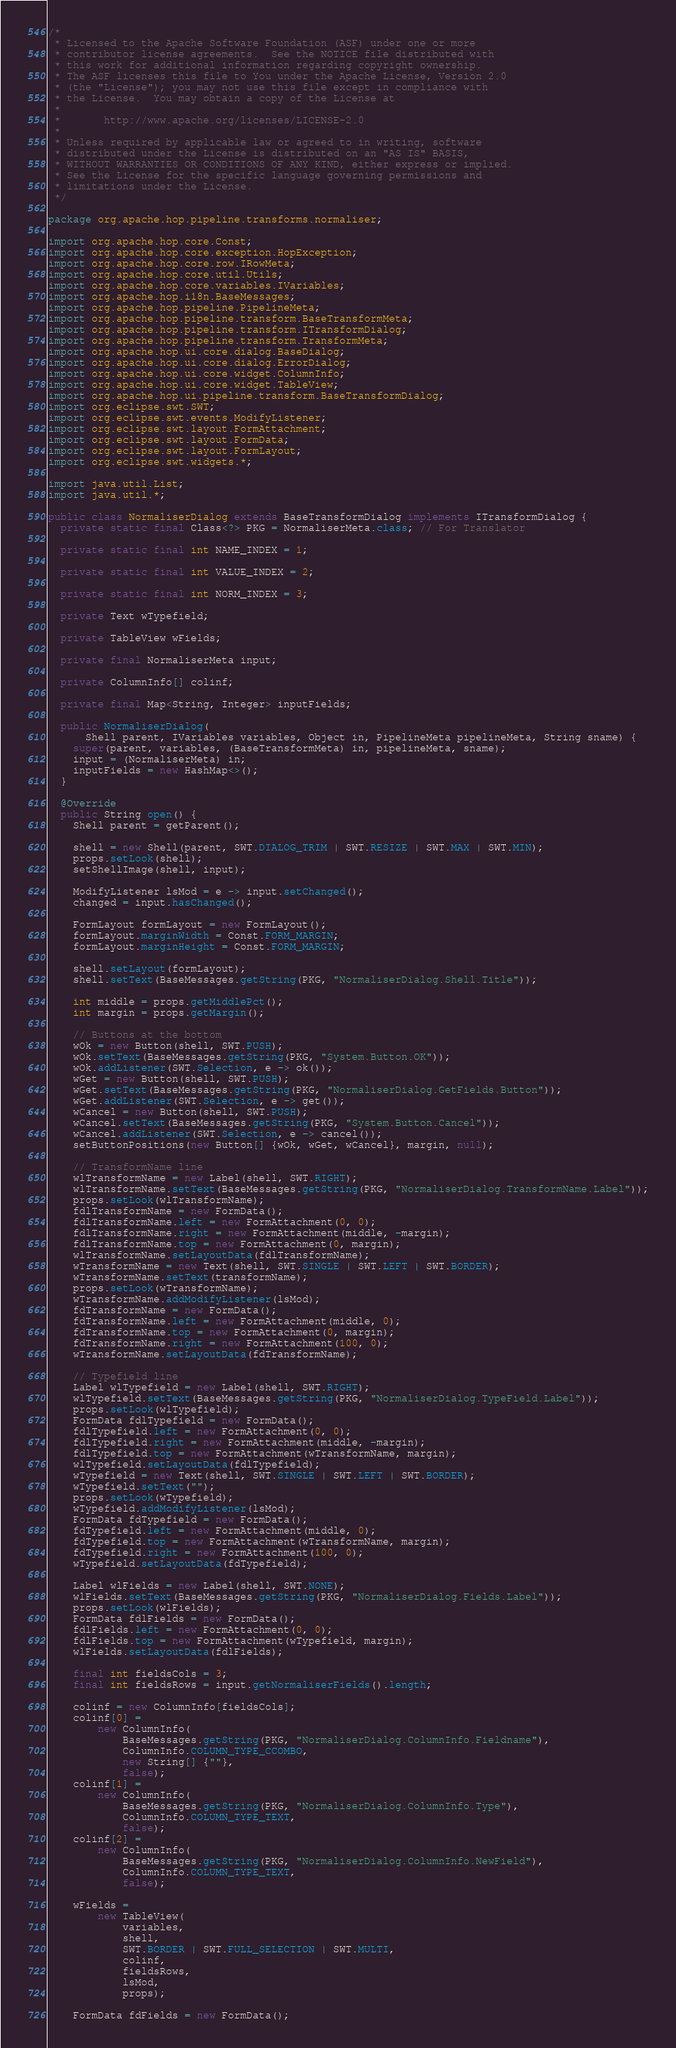Convert code to text. <code><loc_0><loc_0><loc_500><loc_500><_Java_>/*
 * Licensed to the Apache Software Foundation (ASF) under one or more
 * contributor license agreements.  See the NOTICE file distributed with
 * this work for additional information regarding copyright ownership.
 * The ASF licenses this file to You under the Apache License, Version 2.0
 * (the "License"); you may not use this file except in compliance with
 * the License.  You may obtain a copy of the License at
 *
 *       http://www.apache.org/licenses/LICENSE-2.0
 *
 * Unless required by applicable law or agreed to in writing, software
 * distributed under the License is distributed on an "AS IS" BASIS,
 * WITHOUT WARRANTIES OR CONDITIONS OF ANY KIND, either express or implied.
 * See the License for the specific language governing permissions and
 * limitations under the License.
 */

package org.apache.hop.pipeline.transforms.normaliser;

import org.apache.hop.core.Const;
import org.apache.hop.core.exception.HopException;
import org.apache.hop.core.row.IRowMeta;
import org.apache.hop.core.util.Utils;
import org.apache.hop.core.variables.IVariables;
import org.apache.hop.i18n.BaseMessages;
import org.apache.hop.pipeline.PipelineMeta;
import org.apache.hop.pipeline.transform.BaseTransformMeta;
import org.apache.hop.pipeline.transform.ITransformDialog;
import org.apache.hop.pipeline.transform.TransformMeta;
import org.apache.hop.ui.core.dialog.BaseDialog;
import org.apache.hop.ui.core.dialog.ErrorDialog;
import org.apache.hop.ui.core.widget.ColumnInfo;
import org.apache.hop.ui.core.widget.TableView;
import org.apache.hop.ui.pipeline.transform.BaseTransformDialog;
import org.eclipse.swt.SWT;
import org.eclipse.swt.events.ModifyListener;
import org.eclipse.swt.layout.FormAttachment;
import org.eclipse.swt.layout.FormData;
import org.eclipse.swt.layout.FormLayout;
import org.eclipse.swt.widgets.*;

import java.util.List;
import java.util.*;

public class NormaliserDialog extends BaseTransformDialog implements ITransformDialog {
  private static final Class<?> PKG = NormaliserMeta.class; // For Translator

  private static final int NAME_INDEX = 1;

  private static final int VALUE_INDEX = 2;

  private static final int NORM_INDEX = 3;

  private Text wTypefield;

  private TableView wFields;

  private final NormaliserMeta input;

  private ColumnInfo[] colinf;

  private final Map<String, Integer> inputFields;

  public NormaliserDialog(
      Shell parent, IVariables variables, Object in, PipelineMeta pipelineMeta, String sname) {
    super(parent, variables, (BaseTransformMeta) in, pipelineMeta, sname);
    input = (NormaliserMeta) in;
    inputFields = new HashMap<>();
  }

  @Override
  public String open() {
    Shell parent = getParent();

    shell = new Shell(parent, SWT.DIALOG_TRIM | SWT.RESIZE | SWT.MAX | SWT.MIN);
    props.setLook(shell);
    setShellImage(shell, input);

    ModifyListener lsMod = e -> input.setChanged();
    changed = input.hasChanged();

    FormLayout formLayout = new FormLayout();
    formLayout.marginWidth = Const.FORM_MARGIN;
    formLayout.marginHeight = Const.FORM_MARGIN;

    shell.setLayout(formLayout);
    shell.setText(BaseMessages.getString(PKG, "NormaliserDialog.Shell.Title"));

    int middle = props.getMiddlePct();
    int margin = props.getMargin();

    // Buttons at the bottom
    wOk = new Button(shell, SWT.PUSH);
    wOk.setText(BaseMessages.getString(PKG, "System.Button.OK"));
    wOk.addListener(SWT.Selection, e -> ok());
    wGet = new Button(shell, SWT.PUSH);
    wGet.setText(BaseMessages.getString(PKG, "NormaliserDialog.GetFields.Button"));
    wGet.addListener(SWT.Selection, e -> get());
    wCancel = new Button(shell, SWT.PUSH);
    wCancel.setText(BaseMessages.getString(PKG, "System.Button.Cancel"));
    wCancel.addListener(SWT.Selection, e -> cancel());
    setButtonPositions(new Button[] {wOk, wGet, wCancel}, margin, null);

    // TransformName line
    wlTransformName = new Label(shell, SWT.RIGHT);
    wlTransformName.setText(BaseMessages.getString(PKG, "NormaliserDialog.TransformName.Label"));
    props.setLook(wlTransformName);
    fdlTransformName = new FormData();
    fdlTransformName.left = new FormAttachment(0, 0);
    fdlTransformName.right = new FormAttachment(middle, -margin);
    fdlTransformName.top = new FormAttachment(0, margin);
    wlTransformName.setLayoutData(fdlTransformName);
    wTransformName = new Text(shell, SWT.SINGLE | SWT.LEFT | SWT.BORDER);
    wTransformName.setText(transformName);
    props.setLook(wTransformName);
    wTransformName.addModifyListener(lsMod);
    fdTransformName = new FormData();
    fdTransformName.left = new FormAttachment(middle, 0);
    fdTransformName.top = new FormAttachment(0, margin);
    fdTransformName.right = new FormAttachment(100, 0);
    wTransformName.setLayoutData(fdTransformName);

    // Typefield line
    Label wlTypefield = new Label(shell, SWT.RIGHT);
    wlTypefield.setText(BaseMessages.getString(PKG, "NormaliserDialog.TypeField.Label"));
    props.setLook(wlTypefield);
    FormData fdlTypefield = new FormData();
    fdlTypefield.left = new FormAttachment(0, 0);
    fdlTypefield.right = new FormAttachment(middle, -margin);
    fdlTypefield.top = new FormAttachment(wTransformName, margin);
    wlTypefield.setLayoutData(fdlTypefield);
    wTypefield = new Text(shell, SWT.SINGLE | SWT.LEFT | SWT.BORDER);
    wTypefield.setText("");
    props.setLook(wTypefield);
    wTypefield.addModifyListener(lsMod);
    FormData fdTypefield = new FormData();
    fdTypefield.left = new FormAttachment(middle, 0);
    fdTypefield.top = new FormAttachment(wTransformName, margin);
    fdTypefield.right = new FormAttachment(100, 0);
    wTypefield.setLayoutData(fdTypefield);

    Label wlFields = new Label(shell, SWT.NONE);
    wlFields.setText(BaseMessages.getString(PKG, "NormaliserDialog.Fields.Label"));
    props.setLook(wlFields);
    FormData fdlFields = new FormData();
    fdlFields.left = new FormAttachment(0, 0);
    fdlFields.top = new FormAttachment(wTypefield, margin);
    wlFields.setLayoutData(fdlFields);

    final int fieldsCols = 3;
    final int fieldsRows = input.getNormaliserFields().length;

    colinf = new ColumnInfo[fieldsCols];
    colinf[0] =
        new ColumnInfo(
            BaseMessages.getString(PKG, "NormaliserDialog.ColumnInfo.Fieldname"),
            ColumnInfo.COLUMN_TYPE_CCOMBO,
            new String[] {""},
            false);
    colinf[1] =
        new ColumnInfo(
            BaseMessages.getString(PKG, "NormaliserDialog.ColumnInfo.Type"),
            ColumnInfo.COLUMN_TYPE_TEXT,
            false);
    colinf[2] =
        new ColumnInfo(
            BaseMessages.getString(PKG, "NormaliserDialog.ColumnInfo.NewField"),
            ColumnInfo.COLUMN_TYPE_TEXT,
            false);

    wFields =
        new TableView(
            variables,
            shell,
            SWT.BORDER | SWT.FULL_SELECTION | SWT.MULTI,
            colinf,
            fieldsRows,
            lsMod,
            props);

    FormData fdFields = new FormData();</code> 